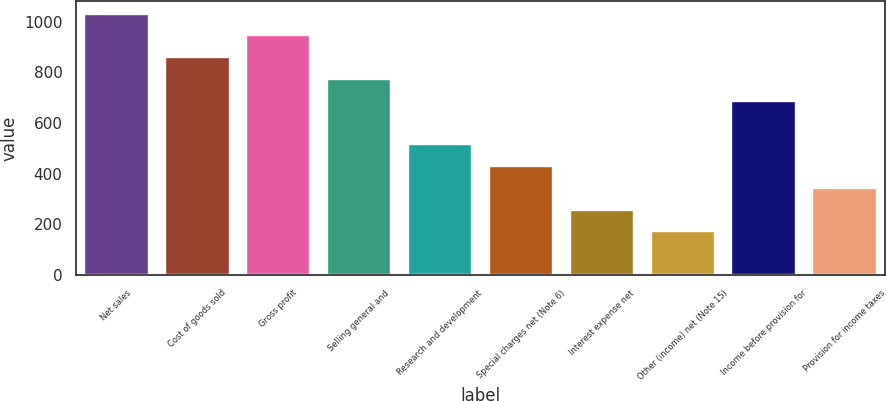Convert chart. <chart><loc_0><loc_0><loc_500><loc_500><bar_chart><fcel>Net sales<fcel>Cost of goods sold<fcel>Gross profit<fcel>Selling general and<fcel>Research and development<fcel>Special charges net (Note 6)<fcel>Interest expense net<fcel>Other (income) net (Note 15)<fcel>Income before provision for<fcel>Provision for income taxes<nl><fcel>1032.33<fcel>860.49<fcel>946.41<fcel>774.57<fcel>516.81<fcel>430.89<fcel>259.05<fcel>173.13<fcel>688.65<fcel>344.97<nl></chart> 